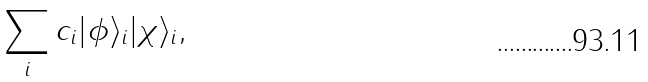Convert formula to latex. <formula><loc_0><loc_0><loc_500><loc_500>\sum _ { i } c _ { i } | \phi \rangle _ { i } | \chi \rangle _ { i } ,</formula> 